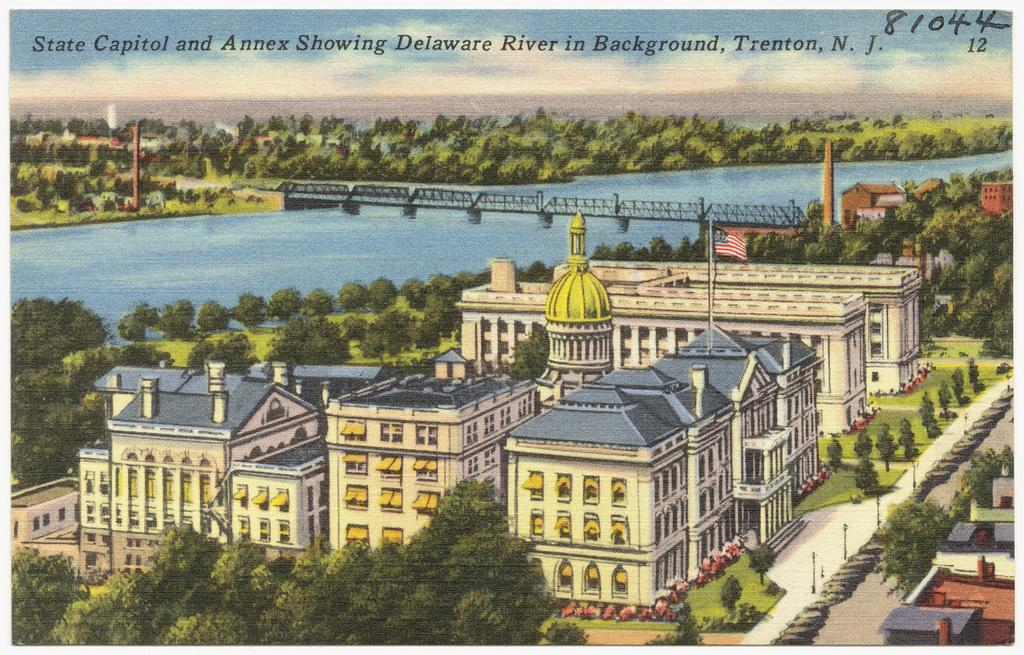<image>
Provide a brief description of the given image. State Capitol and Annex showing the Delaware River from Trenton NJ reads the caption on this postcard. 